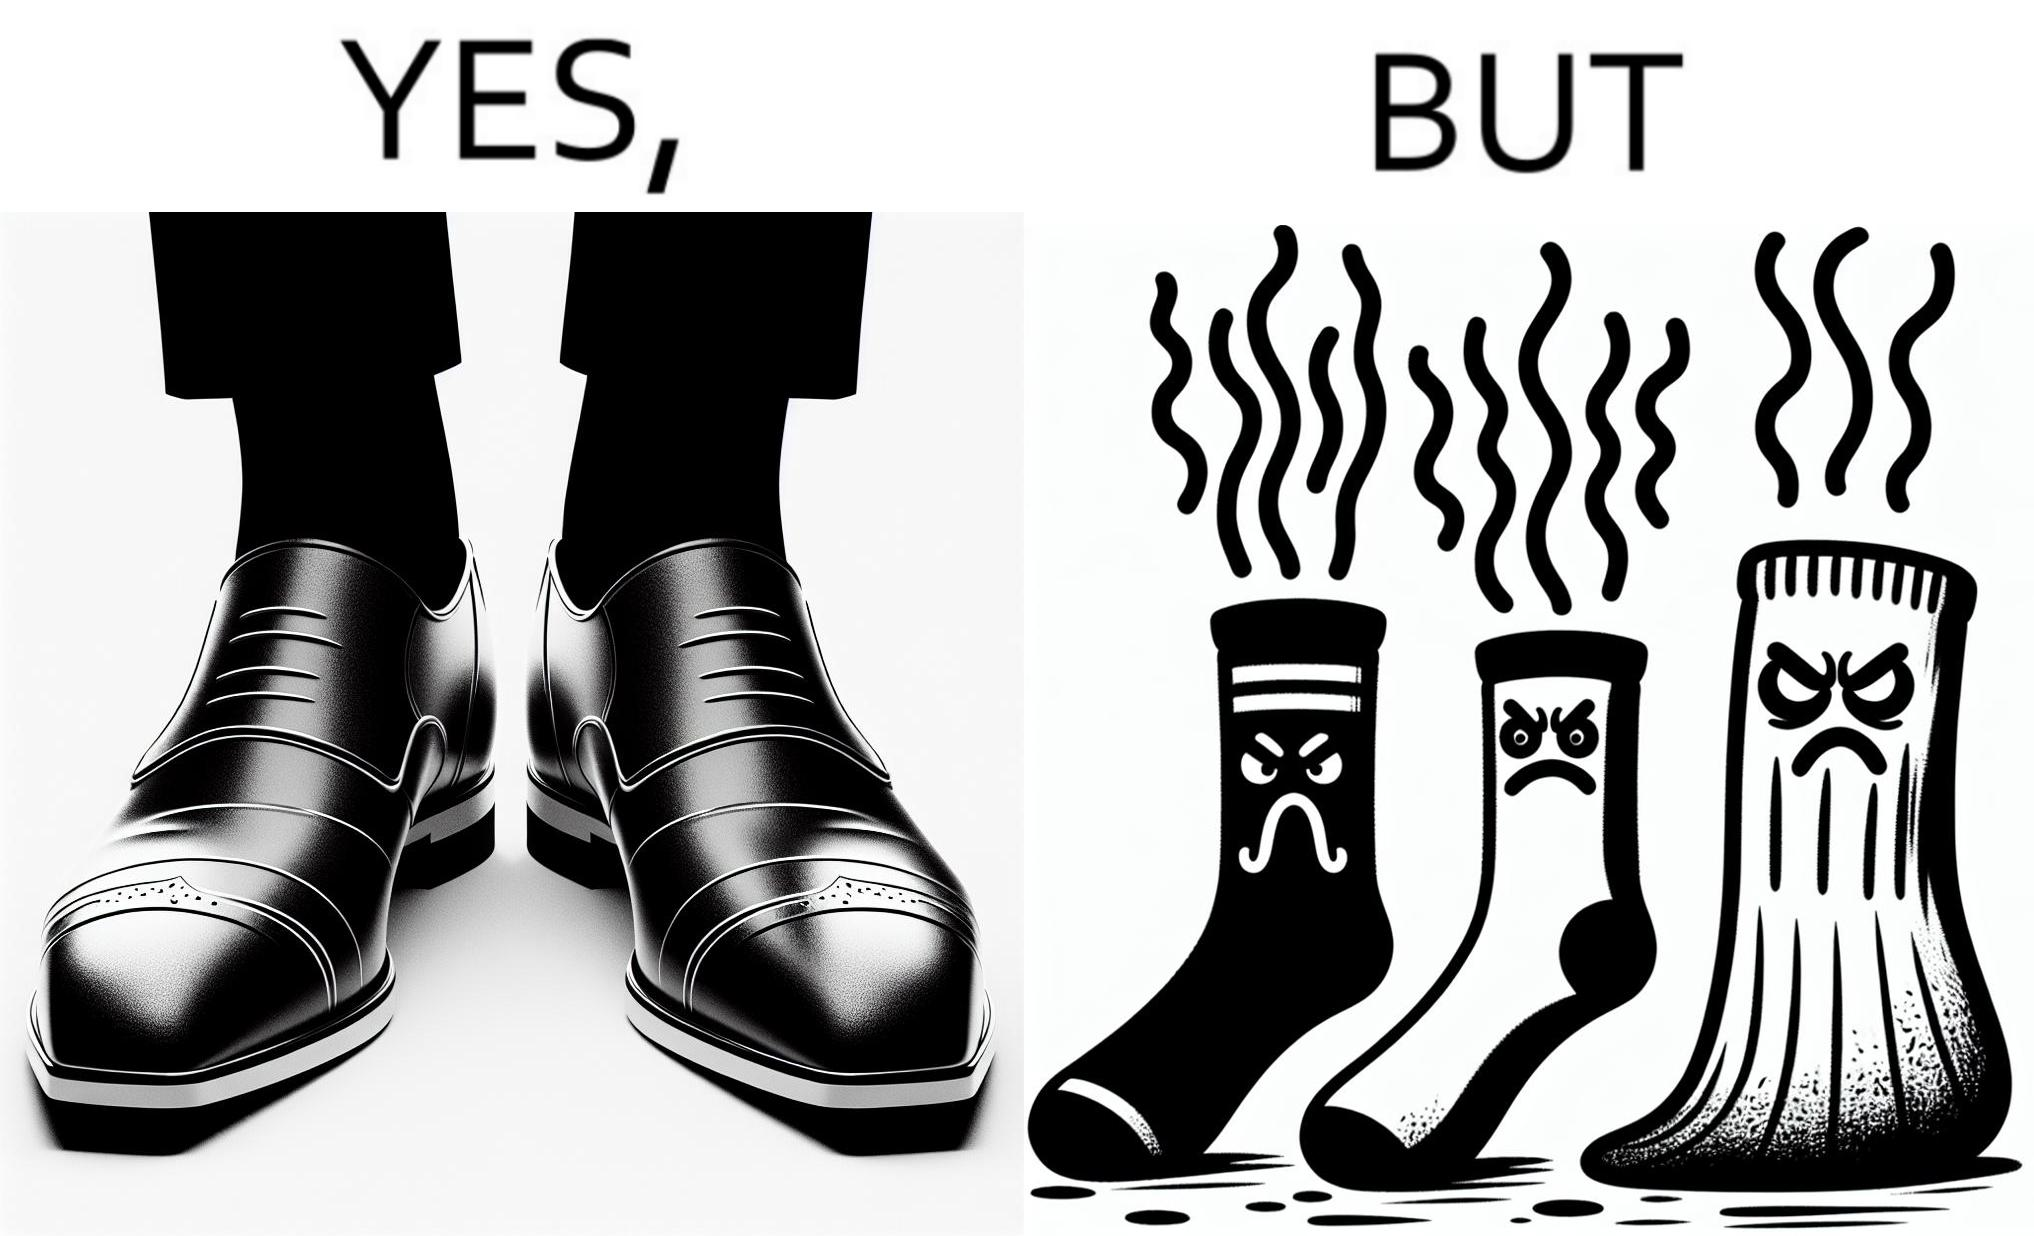Provide a description of this image. The person's shocks is very dirty although the shoes are very clean. Thus there is an irony that not all things are same as they appear. 